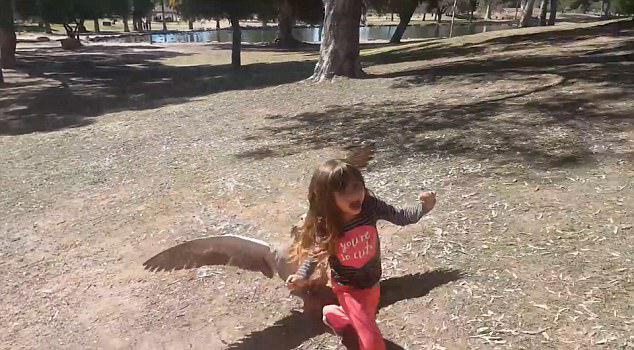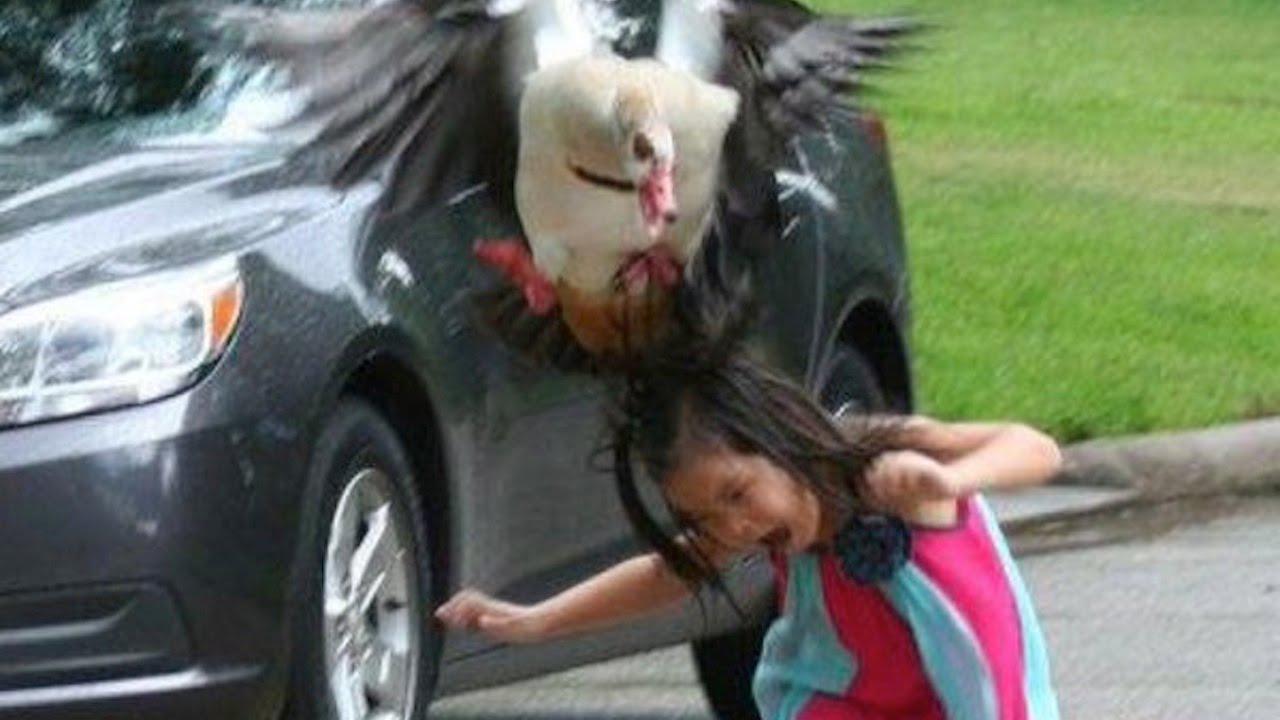The first image is the image on the left, the second image is the image on the right. Evaluate the accuracy of this statement regarding the images: "This a goose white white belly trying to bite a small scared child.". Is it true? Answer yes or no. Yes. 